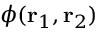<formula> <loc_0><loc_0><loc_500><loc_500>\phi ( r _ { 1 } , r _ { 2 } )</formula> 